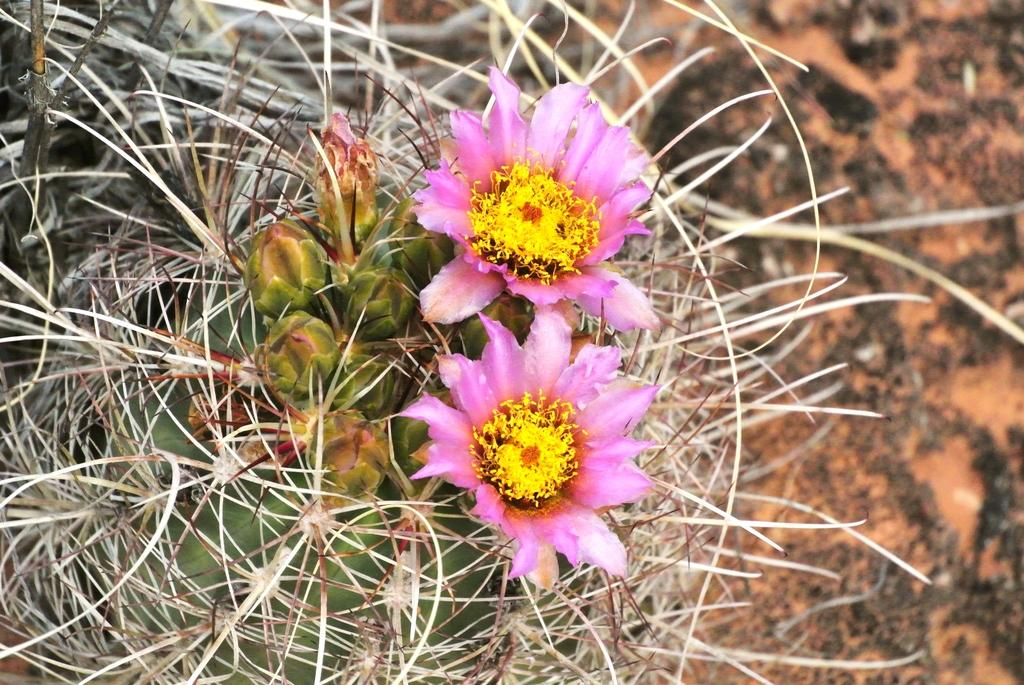What is the main subject in the center of the image? There is a plant in the center of the image. What else can be seen in the image besides the plant? There are flowers in the image. What colors are the flowers? The flowers are in pink and yellow colors. What time does the clock show in the image? There is no clock present in the image. 